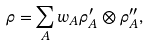Convert formula to latex. <formula><loc_0><loc_0><loc_500><loc_500>\rho = \sum _ { A } w _ { A } \rho ^ { \prime } _ { A } \otimes \rho ^ { \prime \prime } _ { A } ,</formula> 